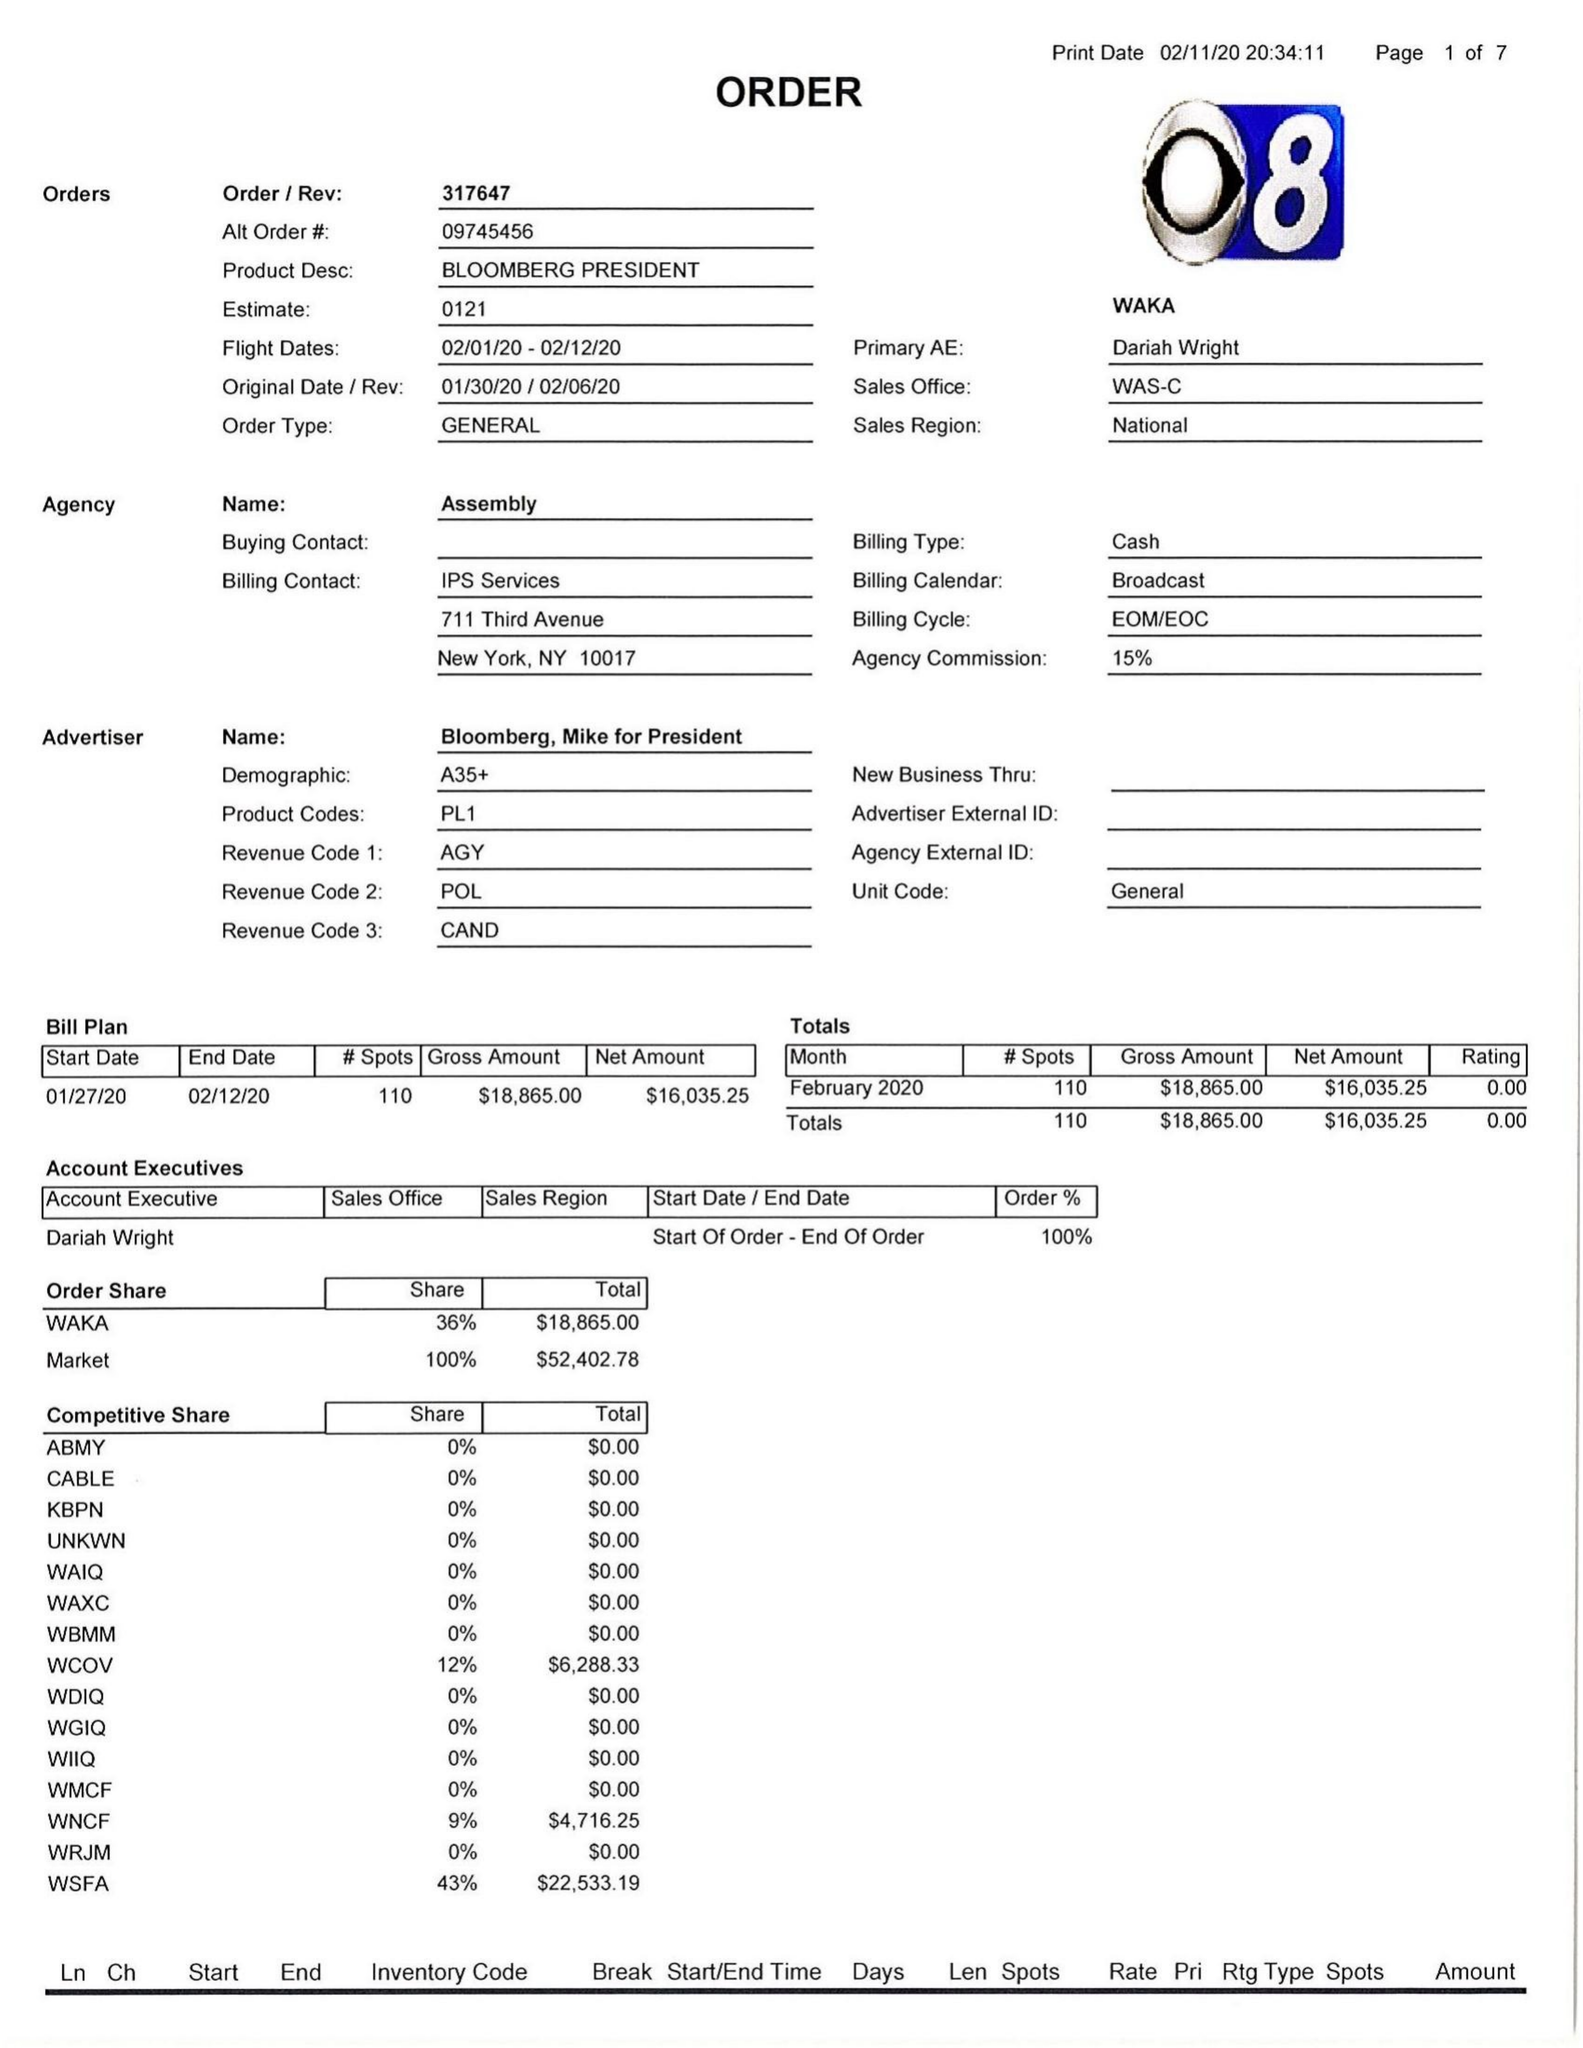What is the value for the flight_from?
Answer the question using a single word or phrase. 02/01/20 